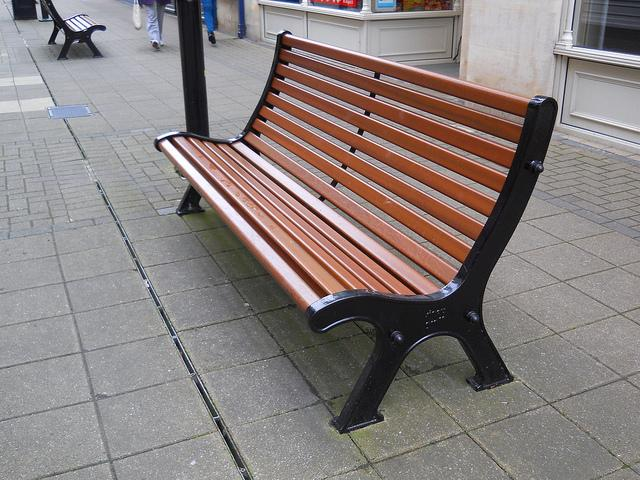This bench is located where?

Choices:
A) ocean front
B) city sidewalk
C) mall
D) park city sidewalk 